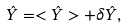<formula> <loc_0><loc_0><loc_500><loc_500>\hat { Y } = < \hat { Y } > + \delta \hat { Y } ,</formula> 